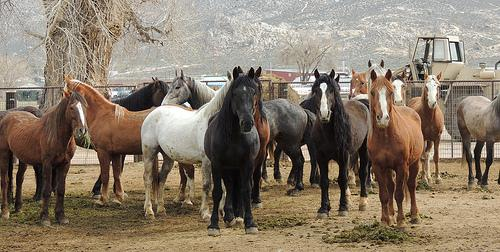Question: what is in the background?
Choices:
A. Wall.
B. Bridge.
C. Mountain.
D. Ocean.
Answer with the letter. Answer: C Question: where in the picture is the farm machine?
Choices:
A. Right.
B. Beside the barn.
C. By the fence.
D. On the man's left.
Answer with the letter. Answer: A Question: what side of the picture are the trees on?
Choices:
A. Right.
B. Left.
C. Left of the fence.
D. Right of the dog.
Answer with the letter. Answer: B Question: how many people are visible?
Choices:
A. 0.
B. 7.
C. 8.
D. 9.
Answer with the letter. Answer: A Question: what animal is pictured?
Choices:
A. Cows.
B. Zebras.
C. Donkeys.
D. Horses.
Answer with the letter. Answer: D 